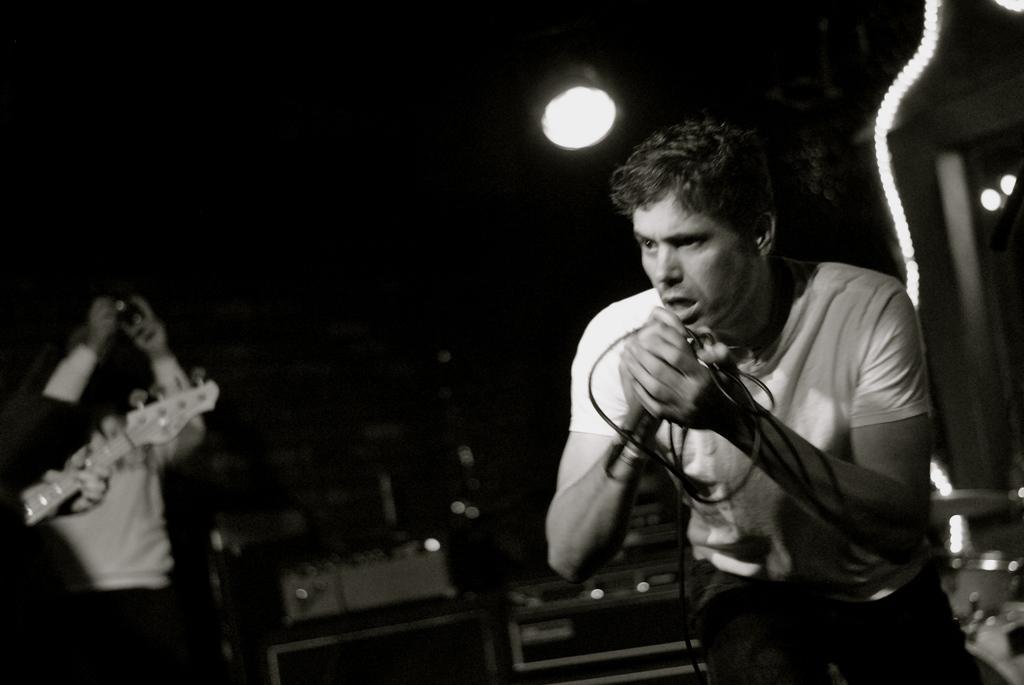Can you describe this image briefly? in this image there are two persons and one person is singing the song and another person is playing the guitar and their are some instruments are there on the stage and background is very dark. 